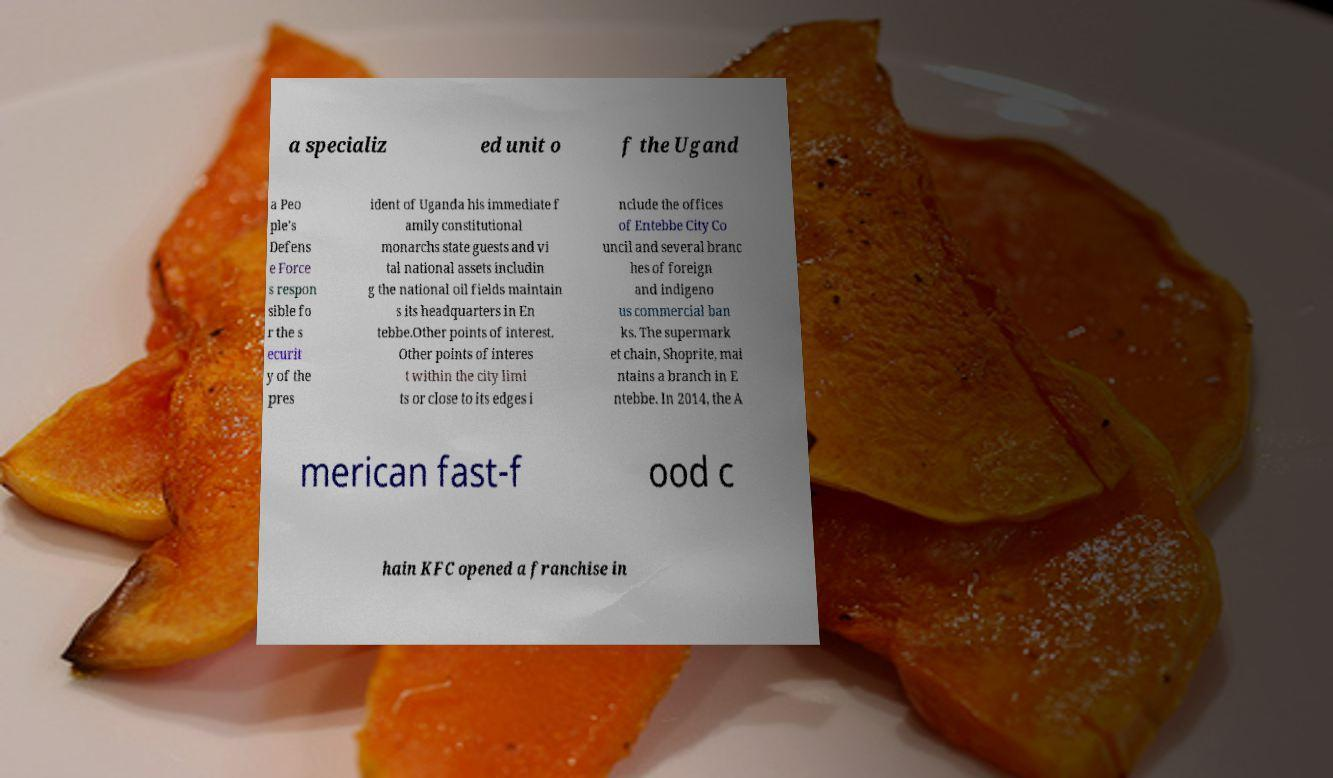For documentation purposes, I need the text within this image transcribed. Could you provide that? a specializ ed unit o f the Ugand a Peo ple's Defens e Force s respon sible fo r the s ecurit y of the pres ident of Uganda his immediate f amily constitutional monarchs state guests and vi tal national assets includin g the national oil fields maintain s its headquarters in En tebbe.Other points of interest. Other points of interes t within the city limi ts or close to its edges i nclude the offices of Entebbe City Co uncil and several branc hes of foreign and indigeno us commercial ban ks. The supermark et chain, Shoprite, mai ntains a branch in E ntebbe. In 2014, the A merican fast-f ood c hain KFC opened a franchise in 